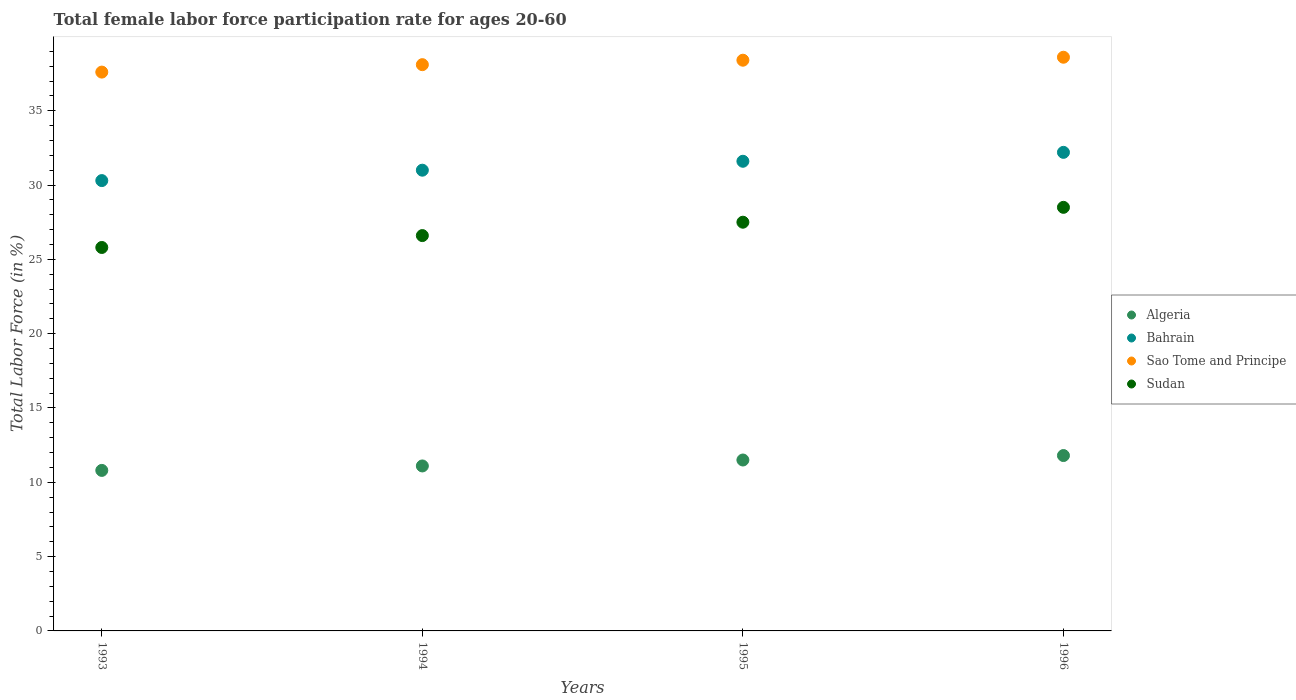What is the female labor force participation rate in Bahrain in 1995?
Provide a short and direct response. 31.6. Across all years, what is the maximum female labor force participation rate in Bahrain?
Offer a terse response. 32.2. Across all years, what is the minimum female labor force participation rate in Bahrain?
Offer a very short reply. 30.3. In which year was the female labor force participation rate in Sao Tome and Principe minimum?
Ensure brevity in your answer.  1993. What is the total female labor force participation rate in Algeria in the graph?
Give a very brief answer. 45.2. What is the difference between the female labor force participation rate in Sudan in 1995 and that in 1996?
Offer a terse response. -1. What is the difference between the female labor force participation rate in Sudan in 1993 and the female labor force participation rate in Algeria in 1996?
Keep it short and to the point. 14. What is the average female labor force participation rate in Sudan per year?
Keep it short and to the point. 27.1. In the year 1995, what is the difference between the female labor force participation rate in Algeria and female labor force participation rate in Sao Tome and Principe?
Offer a terse response. -26.9. In how many years, is the female labor force participation rate in Algeria greater than 10 %?
Offer a very short reply. 4. What is the ratio of the female labor force participation rate in Sao Tome and Principe in 1995 to that in 1996?
Your answer should be very brief. 0.99. Is the difference between the female labor force participation rate in Algeria in 1994 and 1996 greater than the difference between the female labor force participation rate in Sao Tome and Principe in 1994 and 1996?
Your answer should be very brief. No. Is the sum of the female labor force participation rate in Bahrain in 1993 and 1995 greater than the maximum female labor force participation rate in Sudan across all years?
Your answer should be compact. Yes. Is it the case that in every year, the sum of the female labor force participation rate in Algeria and female labor force participation rate in Sudan  is greater than the sum of female labor force participation rate in Bahrain and female labor force participation rate in Sao Tome and Principe?
Your answer should be compact. No. Is it the case that in every year, the sum of the female labor force participation rate in Sudan and female labor force participation rate in Algeria  is greater than the female labor force participation rate in Bahrain?
Your answer should be very brief. Yes. Is the female labor force participation rate in Bahrain strictly greater than the female labor force participation rate in Sudan over the years?
Provide a short and direct response. Yes. Is the female labor force participation rate in Sudan strictly less than the female labor force participation rate in Bahrain over the years?
Provide a short and direct response. Yes. What is the difference between two consecutive major ticks on the Y-axis?
Your response must be concise. 5. Are the values on the major ticks of Y-axis written in scientific E-notation?
Offer a very short reply. No. Where does the legend appear in the graph?
Give a very brief answer. Center right. What is the title of the graph?
Offer a terse response. Total female labor force participation rate for ages 20-60. Does "Vanuatu" appear as one of the legend labels in the graph?
Offer a very short reply. No. What is the label or title of the X-axis?
Provide a succinct answer. Years. What is the Total Labor Force (in %) of Algeria in 1993?
Your response must be concise. 10.8. What is the Total Labor Force (in %) of Bahrain in 1993?
Give a very brief answer. 30.3. What is the Total Labor Force (in %) of Sao Tome and Principe in 1993?
Offer a terse response. 37.6. What is the Total Labor Force (in %) in Sudan in 1993?
Provide a short and direct response. 25.8. What is the Total Labor Force (in %) of Algeria in 1994?
Make the answer very short. 11.1. What is the Total Labor Force (in %) of Sao Tome and Principe in 1994?
Provide a succinct answer. 38.1. What is the Total Labor Force (in %) in Sudan in 1994?
Make the answer very short. 26.6. What is the Total Labor Force (in %) in Bahrain in 1995?
Make the answer very short. 31.6. What is the Total Labor Force (in %) of Sao Tome and Principe in 1995?
Your response must be concise. 38.4. What is the Total Labor Force (in %) of Sudan in 1995?
Offer a terse response. 27.5. What is the Total Labor Force (in %) of Algeria in 1996?
Provide a succinct answer. 11.8. What is the Total Labor Force (in %) of Bahrain in 1996?
Ensure brevity in your answer.  32.2. What is the Total Labor Force (in %) of Sao Tome and Principe in 1996?
Ensure brevity in your answer.  38.6. Across all years, what is the maximum Total Labor Force (in %) in Algeria?
Ensure brevity in your answer.  11.8. Across all years, what is the maximum Total Labor Force (in %) in Bahrain?
Offer a very short reply. 32.2. Across all years, what is the maximum Total Labor Force (in %) of Sao Tome and Principe?
Your answer should be compact. 38.6. Across all years, what is the minimum Total Labor Force (in %) of Algeria?
Keep it short and to the point. 10.8. Across all years, what is the minimum Total Labor Force (in %) in Bahrain?
Your answer should be very brief. 30.3. Across all years, what is the minimum Total Labor Force (in %) in Sao Tome and Principe?
Provide a succinct answer. 37.6. Across all years, what is the minimum Total Labor Force (in %) of Sudan?
Give a very brief answer. 25.8. What is the total Total Labor Force (in %) in Algeria in the graph?
Keep it short and to the point. 45.2. What is the total Total Labor Force (in %) in Bahrain in the graph?
Ensure brevity in your answer.  125.1. What is the total Total Labor Force (in %) of Sao Tome and Principe in the graph?
Make the answer very short. 152.7. What is the total Total Labor Force (in %) of Sudan in the graph?
Give a very brief answer. 108.4. What is the difference between the Total Labor Force (in %) of Algeria in 1993 and that in 1994?
Offer a very short reply. -0.3. What is the difference between the Total Labor Force (in %) in Bahrain in 1993 and that in 1994?
Give a very brief answer. -0.7. What is the difference between the Total Labor Force (in %) of Sao Tome and Principe in 1993 and that in 1994?
Keep it short and to the point. -0.5. What is the difference between the Total Labor Force (in %) of Sudan in 1993 and that in 1994?
Your answer should be very brief. -0.8. What is the difference between the Total Labor Force (in %) of Algeria in 1993 and that in 1995?
Your answer should be compact. -0.7. What is the difference between the Total Labor Force (in %) of Sao Tome and Principe in 1993 and that in 1995?
Keep it short and to the point. -0.8. What is the difference between the Total Labor Force (in %) in Sudan in 1993 and that in 1995?
Provide a short and direct response. -1.7. What is the difference between the Total Labor Force (in %) of Bahrain in 1993 and that in 1996?
Give a very brief answer. -1.9. What is the difference between the Total Labor Force (in %) in Sao Tome and Principe in 1993 and that in 1996?
Ensure brevity in your answer.  -1. What is the difference between the Total Labor Force (in %) in Sudan in 1993 and that in 1996?
Keep it short and to the point. -2.7. What is the difference between the Total Labor Force (in %) of Sudan in 1994 and that in 1995?
Keep it short and to the point. -0.9. What is the difference between the Total Labor Force (in %) in Bahrain in 1994 and that in 1996?
Offer a very short reply. -1.2. What is the difference between the Total Labor Force (in %) in Sao Tome and Principe in 1994 and that in 1996?
Offer a terse response. -0.5. What is the difference between the Total Labor Force (in %) of Algeria in 1995 and that in 1996?
Give a very brief answer. -0.3. What is the difference between the Total Labor Force (in %) of Sao Tome and Principe in 1995 and that in 1996?
Keep it short and to the point. -0.2. What is the difference between the Total Labor Force (in %) in Algeria in 1993 and the Total Labor Force (in %) in Bahrain in 1994?
Provide a short and direct response. -20.2. What is the difference between the Total Labor Force (in %) in Algeria in 1993 and the Total Labor Force (in %) in Sao Tome and Principe in 1994?
Keep it short and to the point. -27.3. What is the difference between the Total Labor Force (in %) of Algeria in 1993 and the Total Labor Force (in %) of Sudan in 1994?
Offer a very short reply. -15.8. What is the difference between the Total Labor Force (in %) in Sao Tome and Principe in 1993 and the Total Labor Force (in %) in Sudan in 1994?
Your response must be concise. 11. What is the difference between the Total Labor Force (in %) in Algeria in 1993 and the Total Labor Force (in %) in Bahrain in 1995?
Offer a very short reply. -20.8. What is the difference between the Total Labor Force (in %) of Algeria in 1993 and the Total Labor Force (in %) of Sao Tome and Principe in 1995?
Give a very brief answer. -27.6. What is the difference between the Total Labor Force (in %) in Algeria in 1993 and the Total Labor Force (in %) in Sudan in 1995?
Offer a very short reply. -16.7. What is the difference between the Total Labor Force (in %) in Bahrain in 1993 and the Total Labor Force (in %) in Sao Tome and Principe in 1995?
Provide a short and direct response. -8.1. What is the difference between the Total Labor Force (in %) of Sao Tome and Principe in 1993 and the Total Labor Force (in %) of Sudan in 1995?
Provide a short and direct response. 10.1. What is the difference between the Total Labor Force (in %) in Algeria in 1993 and the Total Labor Force (in %) in Bahrain in 1996?
Provide a short and direct response. -21.4. What is the difference between the Total Labor Force (in %) in Algeria in 1993 and the Total Labor Force (in %) in Sao Tome and Principe in 1996?
Ensure brevity in your answer.  -27.8. What is the difference between the Total Labor Force (in %) of Algeria in 1993 and the Total Labor Force (in %) of Sudan in 1996?
Your answer should be very brief. -17.7. What is the difference between the Total Labor Force (in %) in Bahrain in 1993 and the Total Labor Force (in %) in Sudan in 1996?
Provide a short and direct response. 1.8. What is the difference between the Total Labor Force (in %) of Algeria in 1994 and the Total Labor Force (in %) of Bahrain in 1995?
Your response must be concise. -20.5. What is the difference between the Total Labor Force (in %) in Algeria in 1994 and the Total Labor Force (in %) in Sao Tome and Principe in 1995?
Give a very brief answer. -27.3. What is the difference between the Total Labor Force (in %) in Algeria in 1994 and the Total Labor Force (in %) in Sudan in 1995?
Your answer should be very brief. -16.4. What is the difference between the Total Labor Force (in %) in Bahrain in 1994 and the Total Labor Force (in %) in Sao Tome and Principe in 1995?
Offer a terse response. -7.4. What is the difference between the Total Labor Force (in %) in Bahrain in 1994 and the Total Labor Force (in %) in Sudan in 1995?
Offer a very short reply. 3.5. What is the difference between the Total Labor Force (in %) in Sao Tome and Principe in 1994 and the Total Labor Force (in %) in Sudan in 1995?
Provide a short and direct response. 10.6. What is the difference between the Total Labor Force (in %) of Algeria in 1994 and the Total Labor Force (in %) of Bahrain in 1996?
Ensure brevity in your answer.  -21.1. What is the difference between the Total Labor Force (in %) of Algeria in 1994 and the Total Labor Force (in %) of Sao Tome and Principe in 1996?
Offer a terse response. -27.5. What is the difference between the Total Labor Force (in %) in Algeria in 1994 and the Total Labor Force (in %) in Sudan in 1996?
Provide a succinct answer. -17.4. What is the difference between the Total Labor Force (in %) of Sao Tome and Principe in 1994 and the Total Labor Force (in %) of Sudan in 1996?
Ensure brevity in your answer.  9.6. What is the difference between the Total Labor Force (in %) in Algeria in 1995 and the Total Labor Force (in %) in Bahrain in 1996?
Provide a short and direct response. -20.7. What is the difference between the Total Labor Force (in %) in Algeria in 1995 and the Total Labor Force (in %) in Sao Tome and Principe in 1996?
Ensure brevity in your answer.  -27.1. What is the difference between the Total Labor Force (in %) in Algeria in 1995 and the Total Labor Force (in %) in Sudan in 1996?
Ensure brevity in your answer.  -17. What is the difference between the Total Labor Force (in %) of Bahrain in 1995 and the Total Labor Force (in %) of Sao Tome and Principe in 1996?
Your answer should be compact. -7. What is the difference between the Total Labor Force (in %) of Bahrain in 1995 and the Total Labor Force (in %) of Sudan in 1996?
Provide a succinct answer. 3.1. What is the difference between the Total Labor Force (in %) of Sao Tome and Principe in 1995 and the Total Labor Force (in %) of Sudan in 1996?
Your answer should be compact. 9.9. What is the average Total Labor Force (in %) in Algeria per year?
Provide a short and direct response. 11.3. What is the average Total Labor Force (in %) of Bahrain per year?
Offer a terse response. 31.27. What is the average Total Labor Force (in %) of Sao Tome and Principe per year?
Provide a succinct answer. 38.17. What is the average Total Labor Force (in %) in Sudan per year?
Your answer should be very brief. 27.1. In the year 1993, what is the difference between the Total Labor Force (in %) in Algeria and Total Labor Force (in %) in Bahrain?
Make the answer very short. -19.5. In the year 1993, what is the difference between the Total Labor Force (in %) of Algeria and Total Labor Force (in %) of Sao Tome and Principe?
Your answer should be compact. -26.8. In the year 1994, what is the difference between the Total Labor Force (in %) of Algeria and Total Labor Force (in %) of Bahrain?
Provide a short and direct response. -19.9. In the year 1994, what is the difference between the Total Labor Force (in %) of Algeria and Total Labor Force (in %) of Sao Tome and Principe?
Your answer should be very brief. -27. In the year 1994, what is the difference between the Total Labor Force (in %) of Algeria and Total Labor Force (in %) of Sudan?
Provide a short and direct response. -15.5. In the year 1994, what is the difference between the Total Labor Force (in %) of Bahrain and Total Labor Force (in %) of Sao Tome and Principe?
Offer a very short reply. -7.1. In the year 1994, what is the difference between the Total Labor Force (in %) in Bahrain and Total Labor Force (in %) in Sudan?
Give a very brief answer. 4.4. In the year 1994, what is the difference between the Total Labor Force (in %) of Sao Tome and Principe and Total Labor Force (in %) of Sudan?
Offer a very short reply. 11.5. In the year 1995, what is the difference between the Total Labor Force (in %) of Algeria and Total Labor Force (in %) of Bahrain?
Your answer should be compact. -20.1. In the year 1995, what is the difference between the Total Labor Force (in %) of Algeria and Total Labor Force (in %) of Sao Tome and Principe?
Your response must be concise. -26.9. In the year 1995, what is the difference between the Total Labor Force (in %) in Algeria and Total Labor Force (in %) in Sudan?
Give a very brief answer. -16. In the year 1995, what is the difference between the Total Labor Force (in %) of Bahrain and Total Labor Force (in %) of Sao Tome and Principe?
Keep it short and to the point. -6.8. In the year 1995, what is the difference between the Total Labor Force (in %) in Bahrain and Total Labor Force (in %) in Sudan?
Offer a very short reply. 4.1. In the year 1996, what is the difference between the Total Labor Force (in %) in Algeria and Total Labor Force (in %) in Bahrain?
Provide a short and direct response. -20.4. In the year 1996, what is the difference between the Total Labor Force (in %) of Algeria and Total Labor Force (in %) of Sao Tome and Principe?
Make the answer very short. -26.8. In the year 1996, what is the difference between the Total Labor Force (in %) of Algeria and Total Labor Force (in %) of Sudan?
Your response must be concise. -16.7. In the year 1996, what is the difference between the Total Labor Force (in %) in Bahrain and Total Labor Force (in %) in Sudan?
Offer a very short reply. 3.7. What is the ratio of the Total Labor Force (in %) of Bahrain in 1993 to that in 1994?
Offer a very short reply. 0.98. What is the ratio of the Total Labor Force (in %) in Sao Tome and Principe in 1993 to that in 1994?
Provide a succinct answer. 0.99. What is the ratio of the Total Labor Force (in %) in Sudan in 1993 to that in 1994?
Your response must be concise. 0.97. What is the ratio of the Total Labor Force (in %) of Algeria in 1993 to that in 1995?
Provide a succinct answer. 0.94. What is the ratio of the Total Labor Force (in %) of Bahrain in 1993 to that in 1995?
Make the answer very short. 0.96. What is the ratio of the Total Labor Force (in %) in Sao Tome and Principe in 1993 to that in 1995?
Ensure brevity in your answer.  0.98. What is the ratio of the Total Labor Force (in %) in Sudan in 1993 to that in 1995?
Ensure brevity in your answer.  0.94. What is the ratio of the Total Labor Force (in %) of Algeria in 1993 to that in 1996?
Provide a short and direct response. 0.92. What is the ratio of the Total Labor Force (in %) in Bahrain in 1993 to that in 1996?
Give a very brief answer. 0.94. What is the ratio of the Total Labor Force (in %) in Sao Tome and Principe in 1993 to that in 1996?
Provide a short and direct response. 0.97. What is the ratio of the Total Labor Force (in %) of Sudan in 1993 to that in 1996?
Make the answer very short. 0.91. What is the ratio of the Total Labor Force (in %) in Algeria in 1994 to that in 1995?
Keep it short and to the point. 0.97. What is the ratio of the Total Labor Force (in %) in Sudan in 1994 to that in 1995?
Your answer should be very brief. 0.97. What is the ratio of the Total Labor Force (in %) in Algeria in 1994 to that in 1996?
Your response must be concise. 0.94. What is the ratio of the Total Labor Force (in %) in Bahrain in 1994 to that in 1996?
Make the answer very short. 0.96. What is the ratio of the Total Labor Force (in %) in Sao Tome and Principe in 1994 to that in 1996?
Ensure brevity in your answer.  0.99. What is the ratio of the Total Labor Force (in %) in Algeria in 1995 to that in 1996?
Keep it short and to the point. 0.97. What is the ratio of the Total Labor Force (in %) in Bahrain in 1995 to that in 1996?
Give a very brief answer. 0.98. What is the ratio of the Total Labor Force (in %) in Sudan in 1995 to that in 1996?
Provide a short and direct response. 0.96. What is the difference between the highest and the second highest Total Labor Force (in %) in Algeria?
Provide a succinct answer. 0.3. What is the difference between the highest and the second highest Total Labor Force (in %) in Bahrain?
Provide a succinct answer. 0.6. What is the difference between the highest and the second highest Total Labor Force (in %) of Sudan?
Ensure brevity in your answer.  1. What is the difference between the highest and the lowest Total Labor Force (in %) of Sao Tome and Principe?
Offer a terse response. 1. What is the difference between the highest and the lowest Total Labor Force (in %) of Sudan?
Your response must be concise. 2.7. 